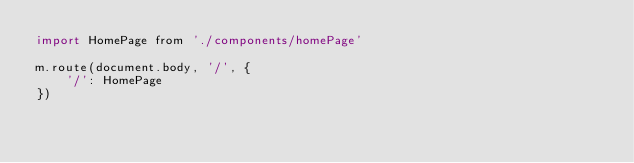<code> <loc_0><loc_0><loc_500><loc_500><_JavaScript_>import HomePage from './components/homePage'

m.route(document.body, '/', {
    '/': HomePage
})</code> 